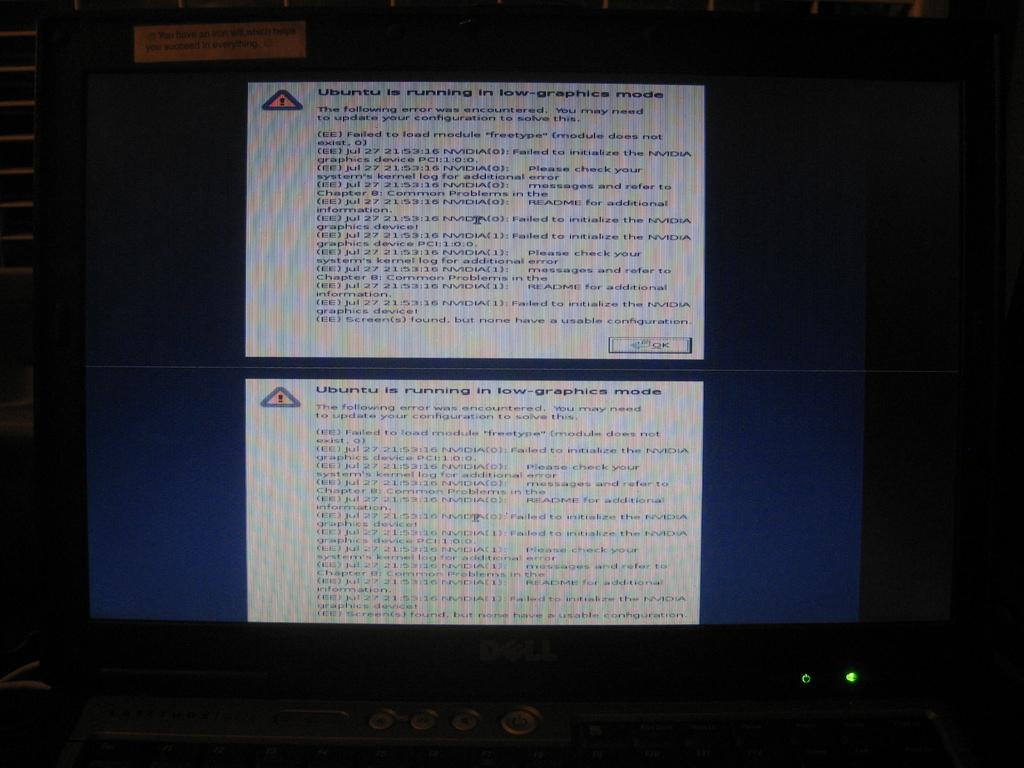What electronic device is present in the image? There is a monitor in the image. What can be seen on the screen of the monitor? There is text on the screen of the monitor, and there are also icons visible. How would you describe the overall lighting in the image? The background of the image is dark. What type of sheet is covering the monitor in the image? There is no sheet covering the monitor in the image. What time of day is depicted in the image? The time of day cannot be determined from the image, as there are no clues or context provided. 